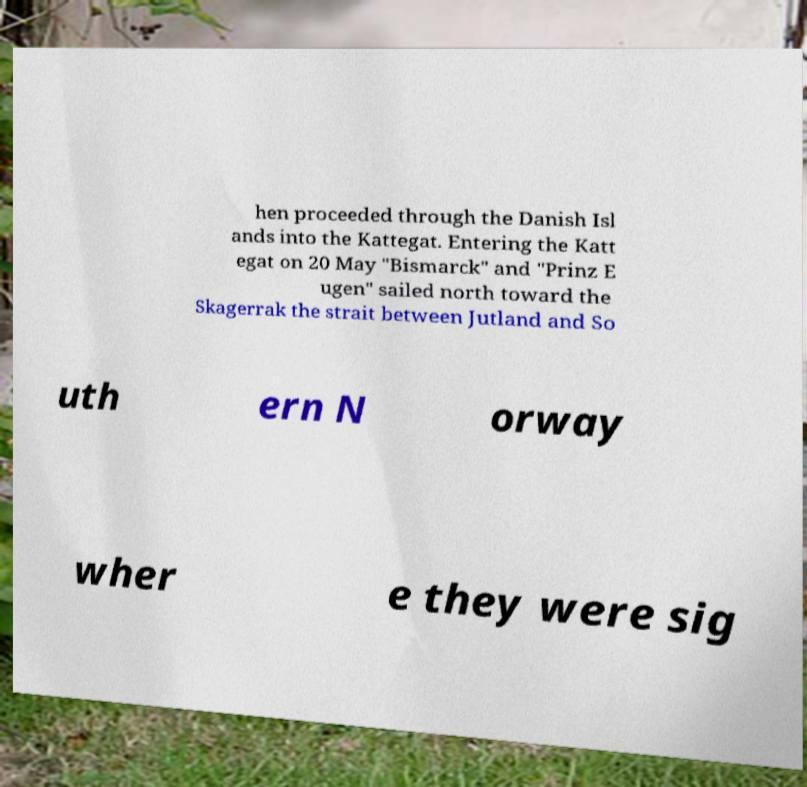Please identify and transcribe the text found in this image. hen proceeded through the Danish Isl ands into the Kattegat. Entering the Katt egat on 20 May "Bismarck" and "Prinz E ugen" sailed north toward the Skagerrak the strait between Jutland and So uth ern N orway wher e they were sig 